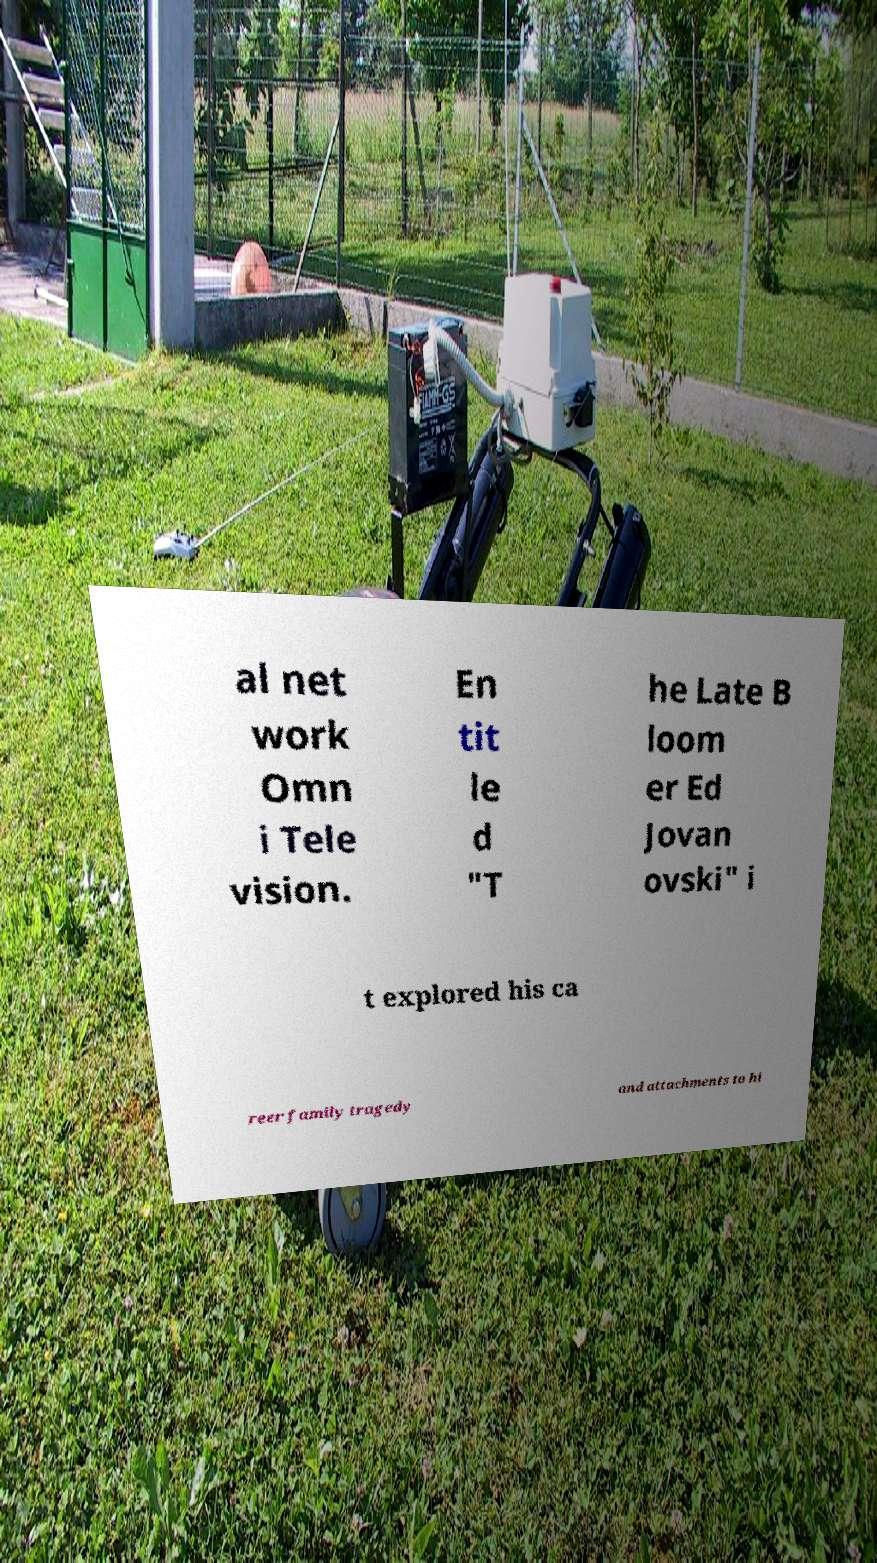I need the written content from this picture converted into text. Can you do that? al net work Omn i Tele vision. En tit le d "T he Late B loom er Ed Jovan ovski" i t explored his ca reer family tragedy and attachments to hi 